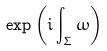Convert formula to latex. <formula><loc_0><loc_0><loc_500><loc_500>\label l { m o n o d r o m y } \exp \left ( i \int _ { \Sigma } \omega \right )</formula> 